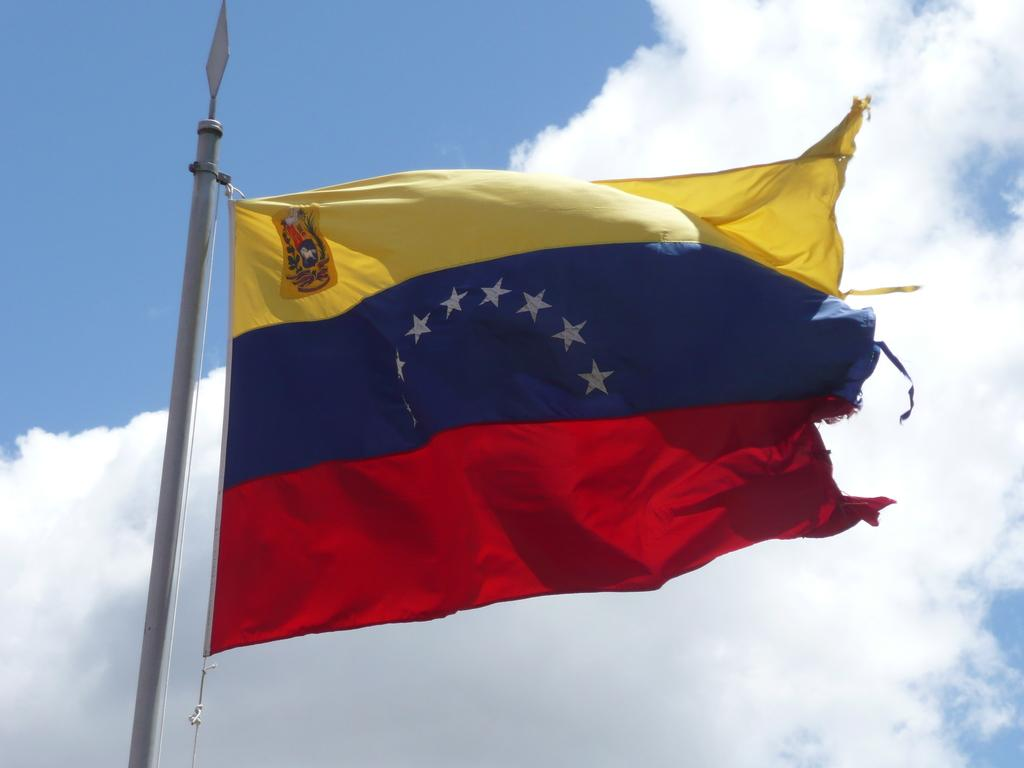What is the main object in the image? There is a flag in the image. How is the flag supported? The flag is attached to a pole. What colors are present on the flag? The flag has yellow, blue, and red colors. What can be seen in the background of the image? There is a sky visible in the background of the image. What is the weather like in the image? The presence of clouds in the sky suggests that it might be partly cloudy. Where is the throne located in the image? There is no throne present in the image. How many balls are visible in the image? There are no balls visible in the image. 